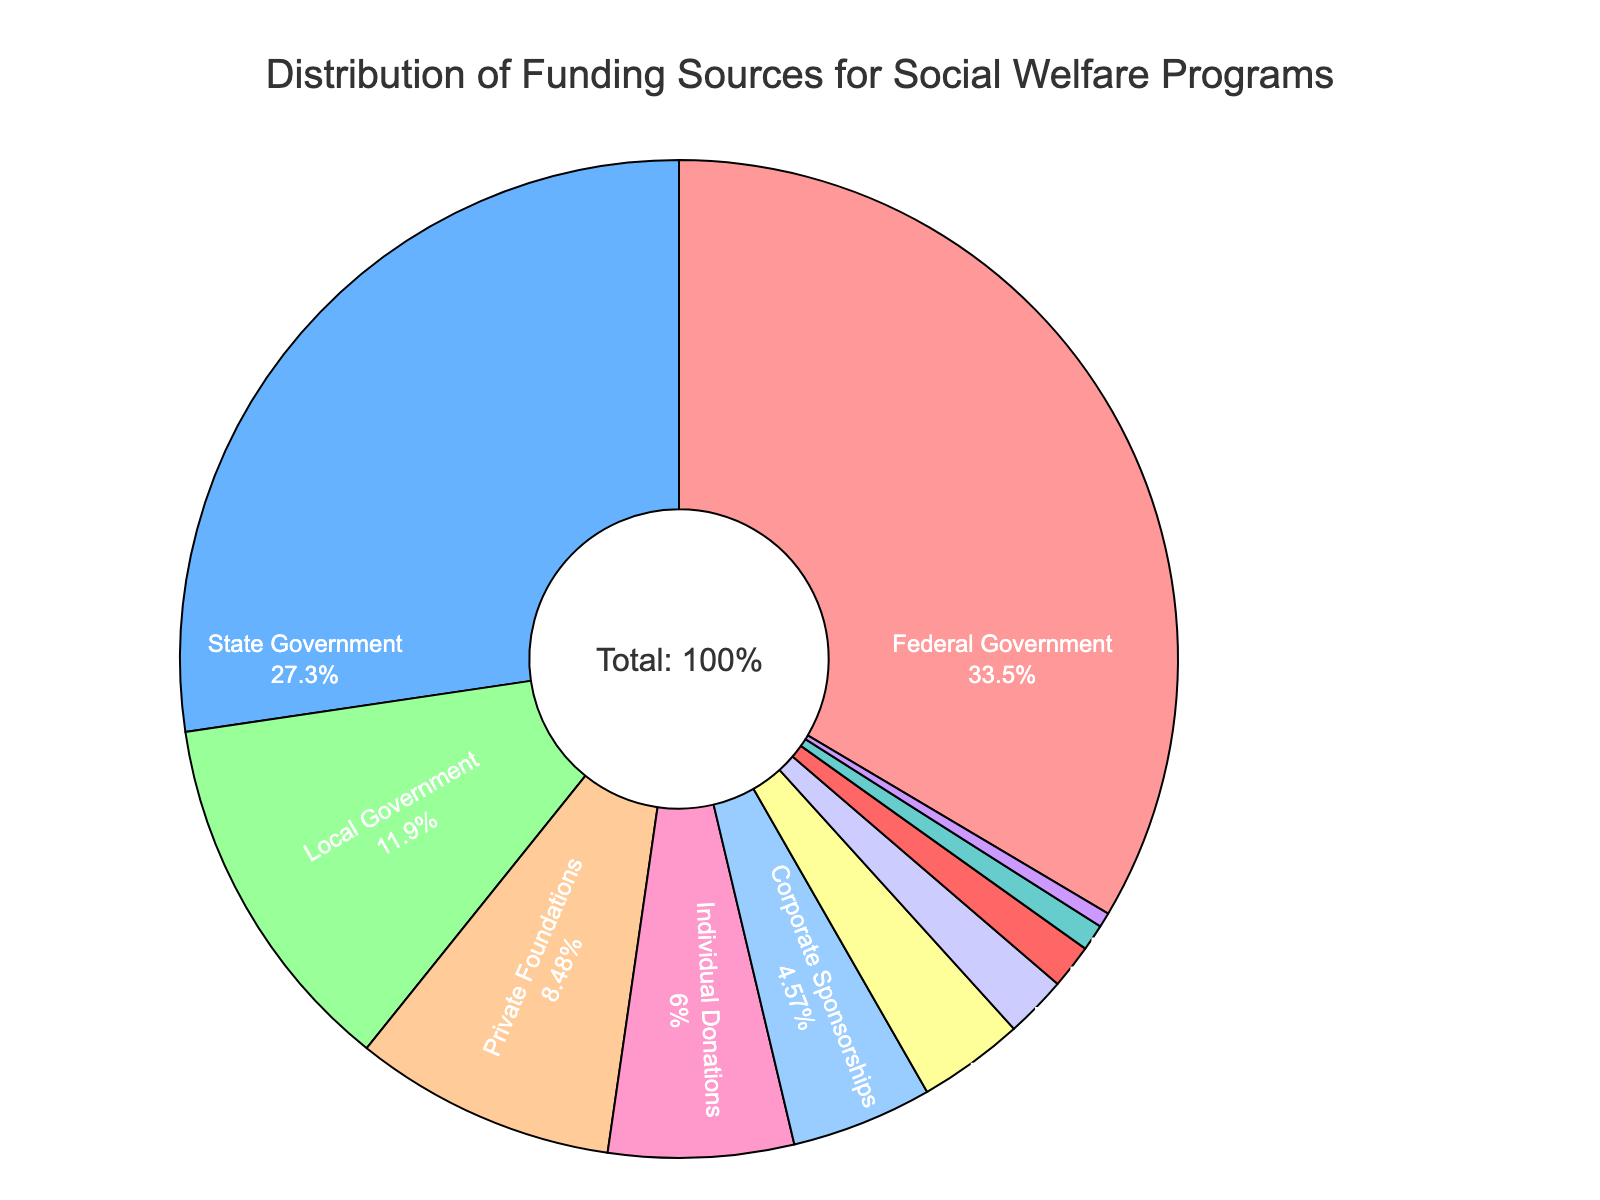Which funding source contributes the most to social welfare programs? Looking at the pie chart, the segment labeled "Federal Government" has the highest percentage value, which is 35.2%.
Answer: Federal Government Which funding source has a smaller contribution: Corporate Sponsorships or Nonprofit Organizations? Comparing the percentages, Corporate Sponsorships have 4.8%, while Nonprofit Organizations have 3.6%. Hence, Nonprofit Organizations contribute less.
Answer: Nonprofit Organizations What is the combined percentage of funding from State Government, Local Government, and Private Foundations? To get the combined percentage, sum the individual percentages: 28.7% (State Government) + 12.5% (Local Government) + 8.9% (Private Foundations) = 50.1%.
Answer: 50.1% Is Individual Donations' contribution greater than the combined contribution of Endowments and Social Impact Bonds? Individual Donations contribute 6.3%. The combined percentage of Endowments (0.5%) and Social Impact Bonds (0.9%) is 0.5% + 0.9% = 1.4%, so 6.3% is greater.
Answer: Yes What is the median percentage value of all funding sources? Listing the percentages in ascending order: 0.5%, 0.9%, 1.5%, 2.1%, 3.6%, 4.8%, 6.3%, 8.9%, 12.5%, 28.7%, 35.2%, the middle value (6th number) is 4.8%.
Answer: 4.8% What percentage of total funding do Community Fundraising Events and Faith-Based Institutions contribute together? By summing their individual percentages: 1.5% (Community Fundraising Events) + 2.1% (Faith-Based Institutions) = 3.6%.
Answer: 3.6% Which colors represent Local Government and Individual Donations in the pie chart? The pie chart uses distinct colors for each segment. Local Government is represented by the fourth color in the sequence used (#FFCC99 or orange-tan), and Individual Donations is represented by the fifth color (#FF99CC or pink) in the list of specified colors.
Answer: Local Government: orange-tan, Individual Donations: pink 